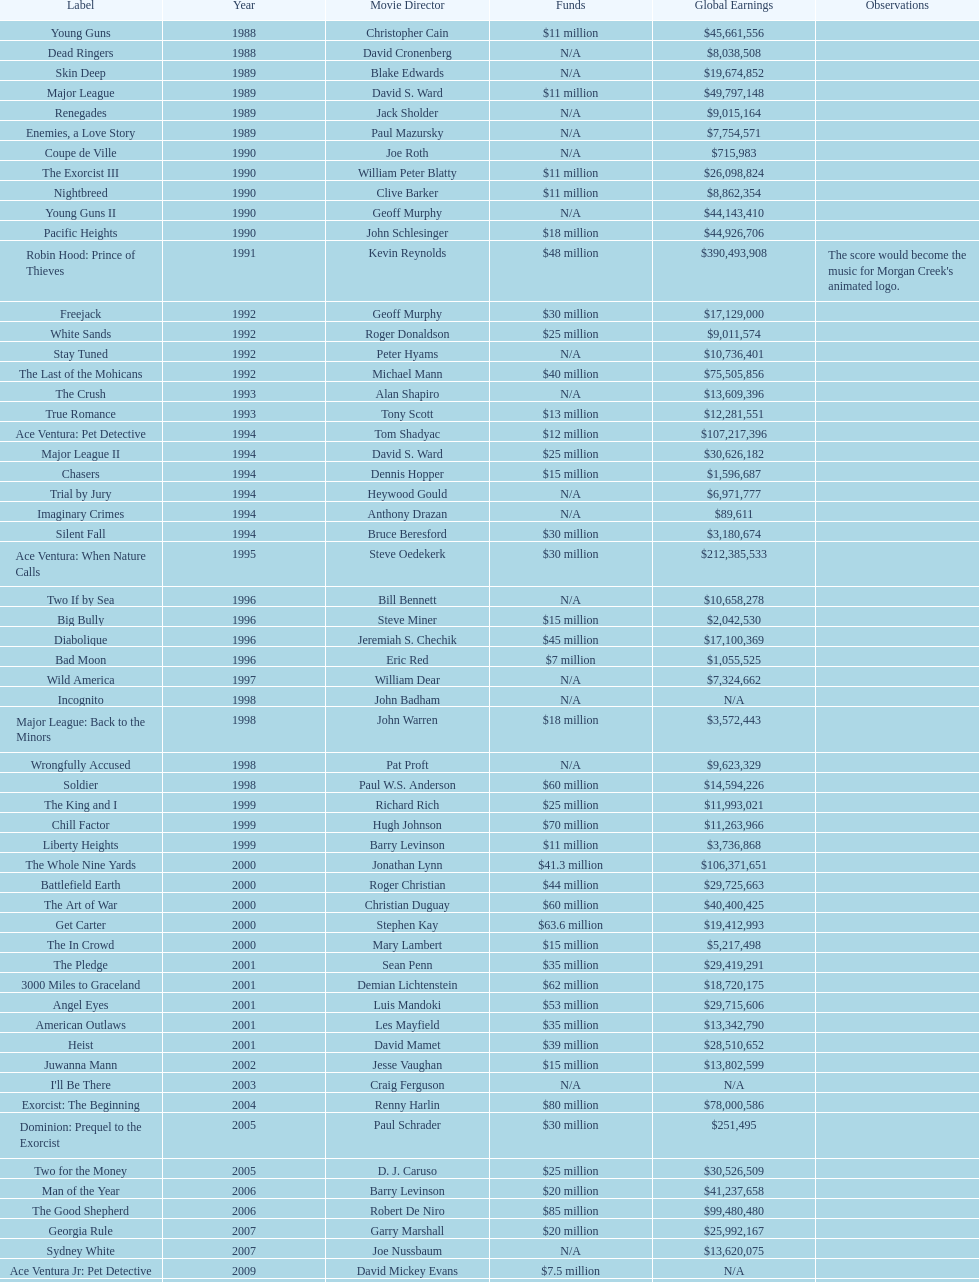How many films were there in 1990? 5. 